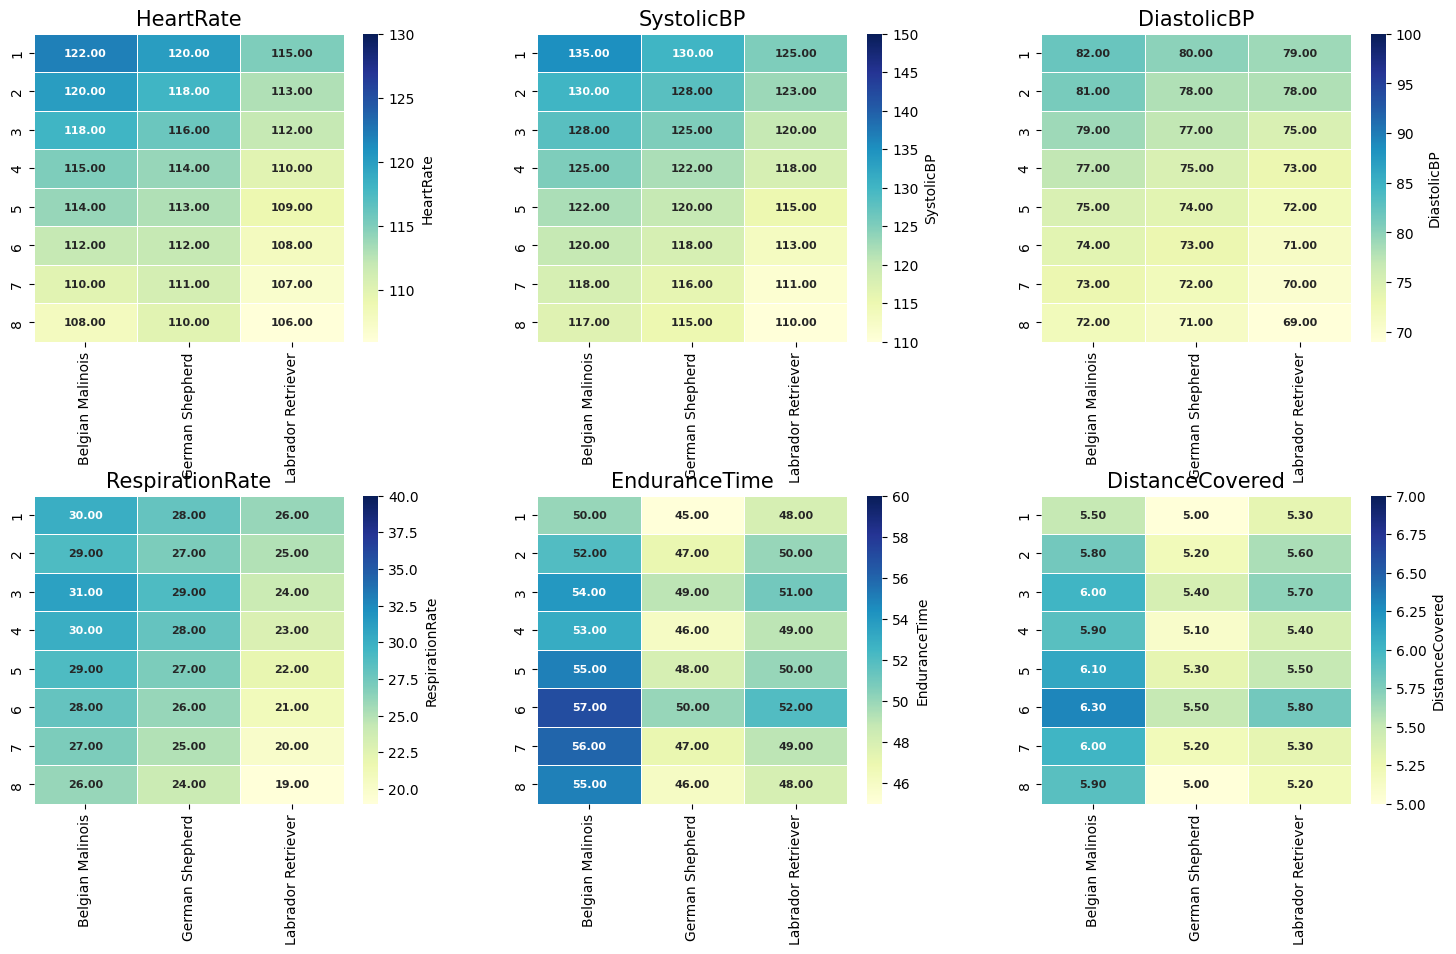What's the average heart rate of the Belgian Malinois over all sessions? To find the average heart rate of the Belgian Malinois, sum all the heart rate values across the sessions and divide by the number of sessions (120 + 118 + 118 + 115 + 114 + 112 + 110 + 108) / 8.
Answer: 114.38 Which breed has the highest distance covered in Session 6? Compare the distance covered values for all breeds in Session 6. The values are: German Shepherd (5.5), Labrador Retriever (5.8), Belgian Malinois (6.3).
Answer: Belgian Malinois In Session 3, which breed has the lowest respiration rate? Check the respiration rates for all breeds in Session 3. The values are: German Shepherd (29), Labrador Retriever (24), Belgian Malinois (31).
Answer: Labrador Retriever Which session shows the lowest systolic blood pressure for the Labrador Retriever? Compare the systolic blood pressure readings across all sessions for the Labrador Retriever. The values are: 125, 123, 120, 118, 115, 113, 111, 110.
Answer: Session 8 What is the difference in endurance time between the German Shepherd and Belgian Malinois in Session 4? Endurance time for the German Shepherd in Session 4 is 46, and for the Belgian Malinois it is 53. Subtract the two values (53 - 46).
Answer: 7 How does the heart rate of the Labrador Retriever in Session 1 compare to that in Session 8? The heart rate in Session 1 is 115 and in Session 8 is 106. Calculate the difference (115 - 106).
Answer: 9 Which breed experienced the greatest increase in endurance time from Session 1 to Session 8? Calculate the difference in endurance time between Session 1 and Session 8 for each breed, then compare the increases.
Answer: Belgian Malinois During which session does the German Shepherd show the lowest diastolic blood pressure? Compare the diastolic blood pressure readings across all sessions for the German Shepherd. The values are: 80, 78, 77, 75, 74, 73, 72, 71.
Answer: Session 8 What is the sum of the respiration rates of all breeds in Session 5? Add the respiration rates for all breeds in Session 5 (27 + 22 + 29).
Answer: 78 